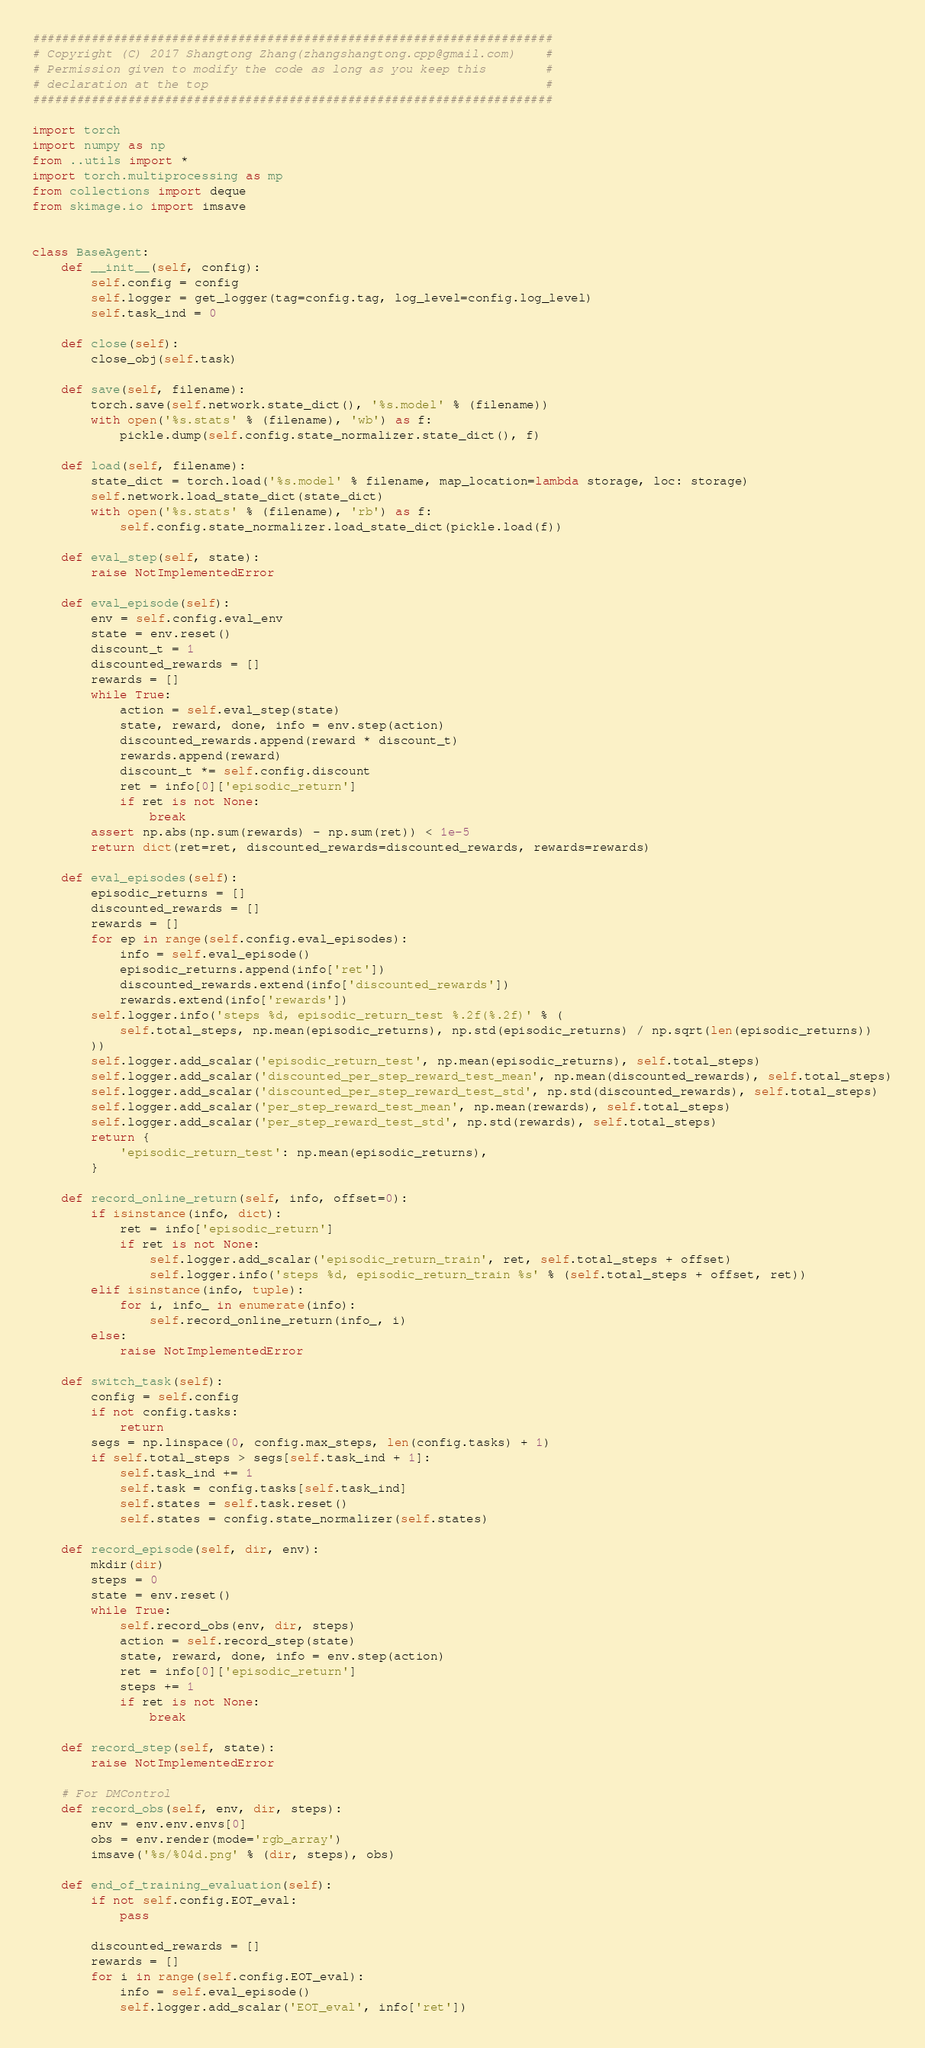<code> <loc_0><loc_0><loc_500><loc_500><_Python_>#######################################################################
# Copyright (C) 2017 Shangtong Zhang(zhangshangtong.cpp@gmail.com)    #
# Permission given to modify the code as long as you keep this        #
# declaration at the top                                              #
#######################################################################

import torch
import numpy as np
from ..utils import *
import torch.multiprocessing as mp
from collections import deque
from skimage.io import imsave


class BaseAgent:
    def __init__(self, config):
        self.config = config
        self.logger = get_logger(tag=config.tag, log_level=config.log_level)
        self.task_ind = 0

    def close(self):
        close_obj(self.task)

    def save(self, filename):
        torch.save(self.network.state_dict(), '%s.model' % (filename))
        with open('%s.stats' % (filename), 'wb') as f:
            pickle.dump(self.config.state_normalizer.state_dict(), f)

    def load(self, filename):
        state_dict = torch.load('%s.model' % filename, map_location=lambda storage, loc: storage)
        self.network.load_state_dict(state_dict)
        with open('%s.stats' % (filename), 'rb') as f:
            self.config.state_normalizer.load_state_dict(pickle.load(f))

    def eval_step(self, state):
        raise NotImplementedError

    def eval_episode(self):
        env = self.config.eval_env
        state = env.reset()
        discount_t = 1
        discounted_rewards = []
        rewards = []
        while True:
            action = self.eval_step(state)
            state, reward, done, info = env.step(action)
            discounted_rewards.append(reward * discount_t)
            rewards.append(reward)
            discount_t *= self.config.discount
            ret = info[0]['episodic_return']
            if ret is not None:
                break
        assert np.abs(np.sum(rewards) - np.sum(ret)) < 1e-5
        return dict(ret=ret, discounted_rewards=discounted_rewards, rewards=rewards)

    def eval_episodes(self):
        episodic_returns = []
        discounted_rewards = []
        rewards = []
        for ep in range(self.config.eval_episodes):
            info = self.eval_episode()
            episodic_returns.append(info['ret'])
            discounted_rewards.extend(info['discounted_rewards'])
            rewards.extend(info['rewards'])
        self.logger.info('steps %d, episodic_return_test %.2f(%.2f)' % (
            self.total_steps, np.mean(episodic_returns), np.std(episodic_returns) / np.sqrt(len(episodic_returns))
        ))
        self.logger.add_scalar('episodic_return_test', np.mean(episodic_returns), self.total_steps)
        self.logger.add_scalar('discounted_per_step_reward_test_mean', np.mean(discounted_rewards), self.total_steps)
        self.logger.add_scalar('discounted_per_step_reward_test_std', np.std(discounted_rewards), self.total_steps)
        self.logger.add_scalar('per_step_reward_test_mean', np.mean(rewards), self.total_steps)
        self.logger.add_scalar('per_step_reward_test_std', np.std(rewards), self.total_steps)
        return {
            'episodic_return_test': np.mean(episodic_returns),
        }

    def record_online_return(self, info, offset=0):
        if isinstance(info, dict):
            ret = info['episodic_return']
            if ret is not None:
                self.logger.add_scalar('episodic_return_train', ret, self.total_steps + offset)
                self.logger.info('steps %d, episodic_return_train %s' % (self.total_steps + offset, ret))
        elif isinstance(info, tuple):
            for i, info_ in enumerate(info):
                self.record_online_return(info_, i)
        else:
            raise NotImplementedError

    def switch_task(self):
        config = self.config
        if not config.tasks:
            return
        segs = np.linspace(0, config.max_steps, len(config.tasks) + 1)
        if self.total_steps > segs[self.task_ind + 1]:
            self.task_ind += 1
            self.task = config.tasks[self.task_ind]
            self.states = self.task.reset()
            self.states = config.state_normalizer(self.states)

    def record_episode(self, dir, env):
        mkdir(dir)
        steps = 0
        state = env.reset()
        while True:
            self.record_obs(env, dir, steps)
            action = self.record_step(state)
            state, reward, done, info = env.step(action)
            ret = info[0]['episodic_return']
            steps += 1
            if ret is not None:
                break

    def record_step(self, state):
        raise NotImplementedError

    # For DMControl
    def record_obs(self, env, dir, steps):
        env = env.env.envs[0]
        obs = env.render(mode='rgb_array')
        imsave('%s/%04d.png' % (dir, steps), obs)

    def end_of_training_evaluation(self):
        if not self.config.EOT_eval:
            pass

        discounted_rewards = []
        rewards = []
        for i in range(self.config.EOT_eval):
            info = self.eval_episode()
            self.logger.add_scalar('EOT_eval', info['ret'])</code> 